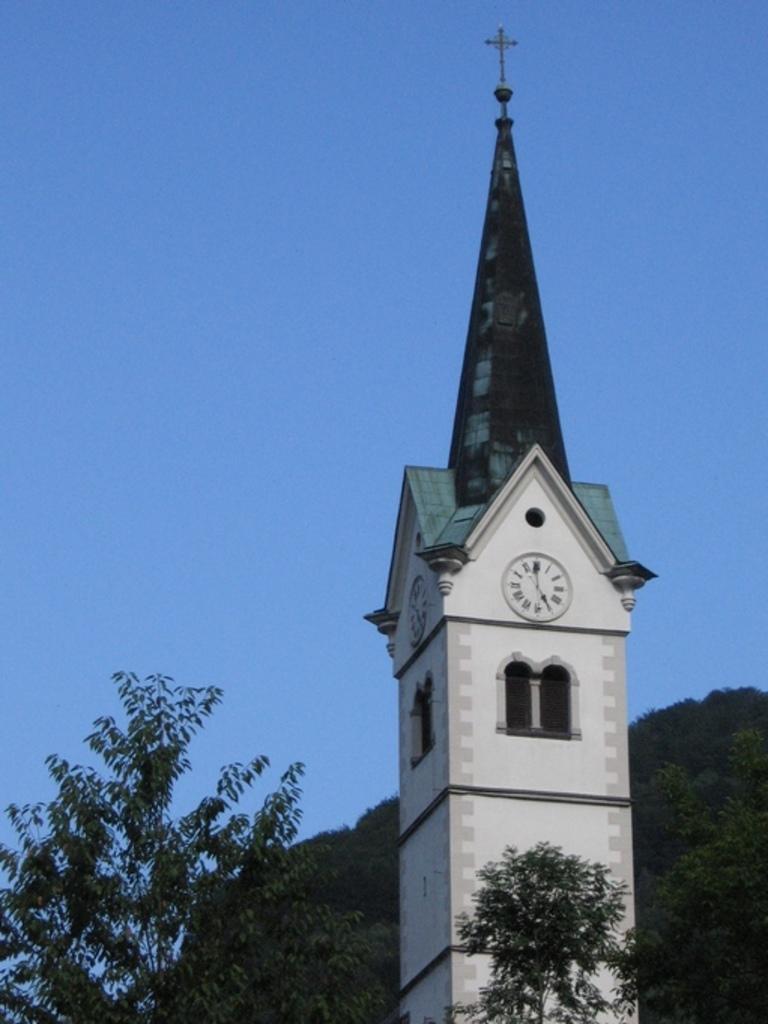Can you describe this image briefly? In this image, I can see a clock tower and the trees. In the background, there is the sky. 